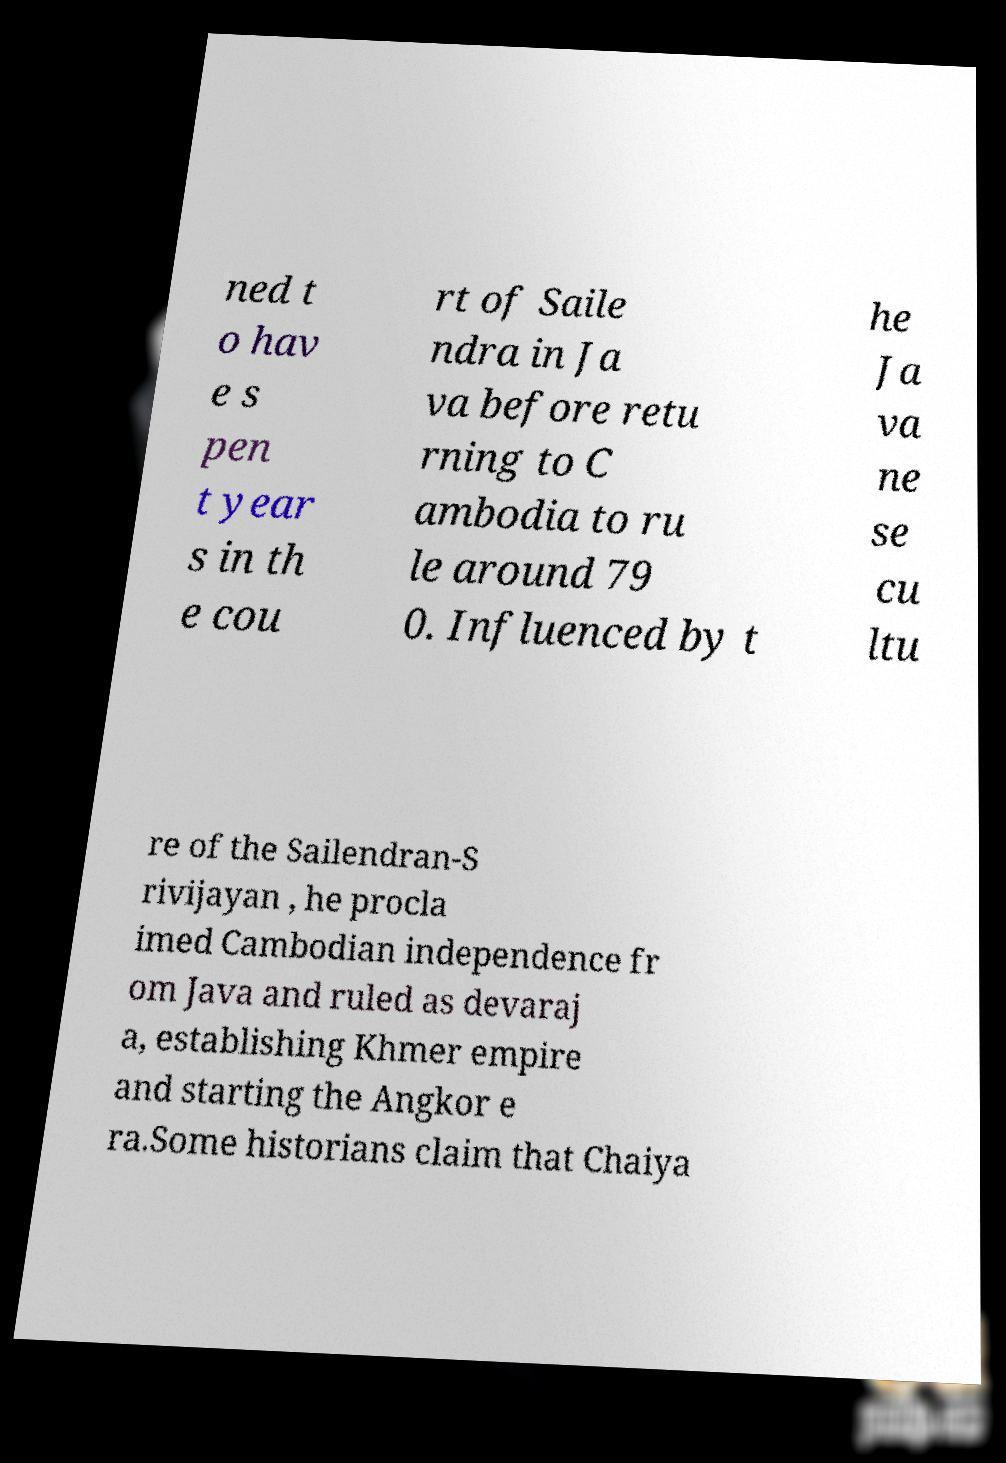Can you read and provide the text displayed in the image?This photo seems to have some interesting text. Can you extract and type it out for me? ned t o hav e s pen t year s in th e cou rt of Saile ndra in Ja va before retu rning to C ambodia to ru le around 79 0. Influenced by t he Ja va ne se cu ltu re of the Sailendran-S rivijayan , he procla imed Cambodian independence fr om Java and ruled as devaraj a, establishing Khmer empire and starting the Angkor e ra.Some historians claim that Chaiya 